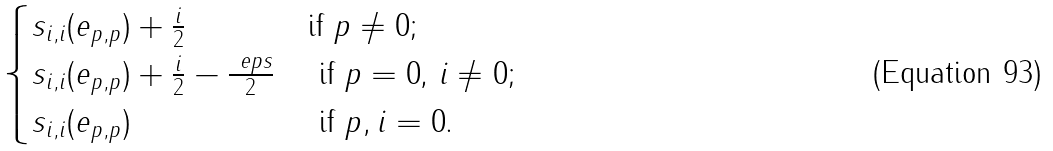Convert formula to latex. <formula><loc_0><loc_0><loc_500><loc_500>\begin{cases} s _ { i , i } ( e _ { p , p } ) + \frac { i } { 2 } & \text {if $p \ne 0$;} \\ s _ { i , i } ( e _ { p , p } ) + \frac { i } { 2 } - \frac { \ e p s } { 2 } & \text { if $p=0$, $i \ne 0$;} \\ s _ { i , i } ( e _ { p , p } ) & \text { if $p,i=0$.} \end{cases}</formula> 